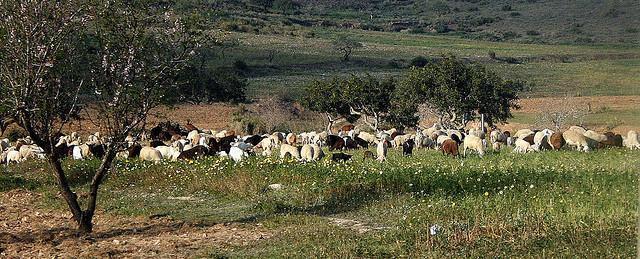What are the animals doing?
From the following four choices, select the correct answer to address the question.
Options: Running, sleeping, resting, working. Resting. 